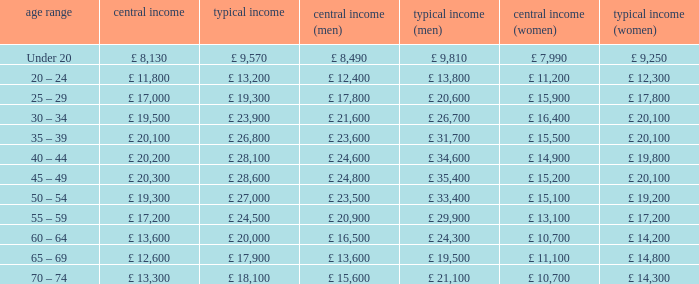Name the median income for age band being under 20 £ 8,130. Could you parse the entire table as a dict? {'header': ['age range', 'central income', 'typical income', 'central income (men)', 'typical income (men)', 'central income (women)', 'typical income (women)'], 'rows': [['Under 20', '£ 8,130', '£ 9,570', '£ 8,490', '£ 9,810', '£ 7,990', '£ 9,250'], ['20 – 24', '£ 11,800', '£ 13,200', '£ 12,400', '£ 13,800', '£ 11,200', '£ 12,300'], ['25 – 29', '£ 17,000', '£ 19,300', '£ 17,800', '£ 20,600', '£ 15,900', '£ 17,800'], ['30 – 34', '£ 19,500', '£ 23,900', '£ 21,600', '£ 26,700', '£ 16,400', '£ 20,100'], ['35 – 39', '£ 20,100', '£ 26,800', '£ 23,600', '£ 31,700', '£ 15,500', '£ 20,100'], ['40 – 44', '£ 20,200', '£ 28,100', '£ 24,600', '£ 34,600', '£ 14,900', '£ 19,800'], ['45 – 49', '£ 20,300', '£ 28,600', '£ 24,800', '£ 35,400', '£ 15,200', '£ 20,100'], ['50 – 54', '£ 19,300', '£ 27,000', '£ 23,500', '£ 33,400', '£ 15,100', '£ 19,200'], ['55 – 59', '£ 17,200', '£ 24,500', '£ 20,900', '£ 29,900', '£ 13,100', '£ 17,200'], ['60 – 64', '£ 13,600', '£ 20,000', '£ 16,500', '£ 24,300', '£ 10,700', '£ 14,200'], ['65 – 69', '£ 12,600', '£ 17,900', '£ 13,600', '£ 19,500', '£ 11,100', '£ 14,800'], ['70 – 74', '£ 13,300', '£ 18,100', '£ 15,600', '£ 21,100', '£ 10,700', '£ 14,300']]} 